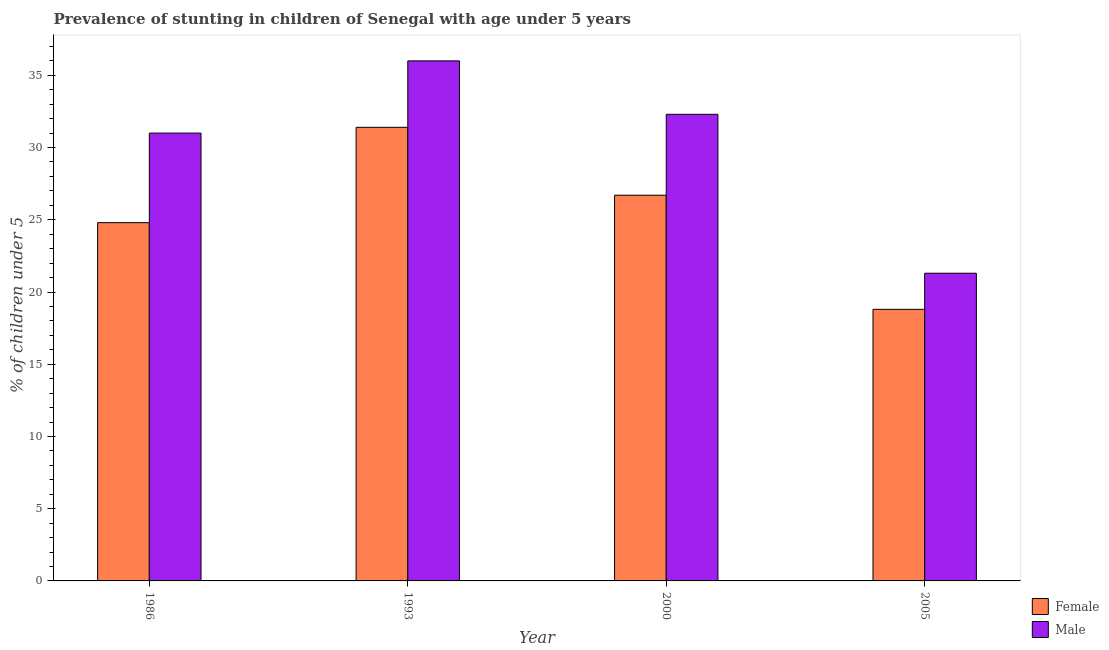How many groups of bars are there?
Your answer should be compact. 4. Are the number of bars per tick equal to the number of legend labels?
Offer a very short reply. Yes. Are the number of bars on each tick of the X-axis equal?
Ensure brevity in your answer.  Yes. How many bars are there on the 2nd tick from the right?
Keep it short and to the point. 2. What is the label of the 2nd group of bars from the left?
Offer a very short reply. 1993. What is the percentage of stunted male children in 1986?
Make the answer very short. 31. Across all years, what is the minimum percentage of stunted female children?
Your answer should be very brief. 18.8. In which year was the percentage of stunted male children minimum?
Provide a short and direct response. 2005. What is the total percentage of stunted male children in the graph?
Ensure brevity in your answer.  120.6. What is the difference between the percentage of stunted male children in 2005 and the percentage of stunted female children in 1986?
Make the answer very short. -9.7. What is the average percentage of stunted male children per year?
Your answer should be very brief. 30.15. What is the ratio of the percentage of stunted female children in 1986 to that in 2000?
Provide a succinct answer. 0.93. Is the difference between the percentage of stunted female children in 1993 and 2000 greater than the difference between the percentage of stunted male children in 1993 and 2000?
Give a very brief answer. No. What is the difference between the highest and the second highest percentage of stunted female children?
Keep it short and to the point. 4.7. What is the difference between the highest and the lowest percentage of stunted male children?
Offer a very short reply. 14.7. Is the sum of the percentage of stunted female children in 1986 and 2000 greater than the maximum percentage of stunted male children across all years?
Ensure brevity in your answer.  Yes. What does the 1st bar from the left in 2005 represents?
Give a very brief answer. Female. What does the 2nd bar from the right in 1993 represents?
Ensure brevity in your answer.  Female. How many bars are there?
Ensure brevity in your answer.  8. How many years are there in the graph?
Offer a terse response. 4. Are the values on the major ticks of Y-axis written in scientific E-notation?
Keep it short and to the point. No. Where does the legend appear in the graph?
Make the answer very short. Bottom right. How many legend labels are there?
Keep it short and to the point. 2. What is the title of the graph?
Provide a short and direct response. Prevalence of stunting in children of Senegal with age under 5 years. Does "Registered firms" appear as one of the legend labels in the graph?
Ensure brevity in your answer.  No. What is the label or title of the Y-axis?
Make the answer very short.  % of children under 5. What is the  % of children under 5 in Female in 1986?
Make the answer very short. 24.8. What is the  % of children under 5 in Male in 1986?
Your answer should be compact. 31. What is the  % of children under 5 of Female in 1993?
Offer a very short reply. 31.4. What is the  % of children under 5 of Male in 1993?
Offer a terse response. 36. What is the  % of children under 5 in Female in 2000?
Provide a short and direct response. 26.7. What is the  % of children under 5 of Male in 2000?
Give a very brief answer. 32.3. What is the  % of children under 5 in Female in 2005?
Your response must be concise. 18.8. What is the  % of children under 5 in Male in 2005?
Ensure brevity in your answer.  21.3. Across all years, what is the maximum  % of children under 5 in Female?
Your answer should be very brief. 31.4. Across all years, what is the maximum  % of children under 5 of Male?
Your answer should be compact. 36. Across all years, what is the minimum  % of children under 5 in Female?
Give a very brief answer. 18.8. Across all years, what is the minimum  % of children under 5 in Male?
Offer a terse response. 21.3. What is the total  % of children under 5 in Female in the graph?
Ensure brevity in your answer.  101.7. What is the total  % of children under 5 of Male in the graph?
Provide a short and direct response. 120.6. What is the difference between the  % of children under 5 in Male in 1986 and that in 1993?
Offer a terse response. -5. What is the difference between the  % of children under 5 in Male in 1986 and that in 2005?
Ensure brevity in your answer.  9.7. What is the difference between the  % of children under 5 in Male in 1993 and that in 2005?
Offer a terse response. 14.7. What is the difference between the  % of children under 5 in Female in 2000 and that in 2005?
Ensure brevity in your answer.  7.9. What is the difference between the  % of children under 5 of Male in 2000 and that in 2005?
Keep it short and to the point. 11. What is the difference between the  % of children under 5 in Female in 1986 and the  % of children under 5 in Male in 2005?
Keep it short and to the point. 3.5. What is the difference between the  % of children under 5 of Female in 1993 and the  % of children under 5 of Male in 2000?
Offer a very short reply. -0.9. What is the difference between the  % of children under 5 of Female in 1993 and the  % of children under 5 of Male in 2005?
Provide a succinct answer. 10.1. What is the difference between the  % of children under 5 in Female in 2000 and the  % of children under 5 in Male in 2005?
Give a very brief answer. 5.4. What is the average  % of children under 5 in Female per year?
Make the answer very short. 25.43. What is the average  % of children under 5 of Male per year?
Ensure brevity in your answer.  30.15. In the year 1986, what is the difference between the  % of children under 5 of Female and  % of children under 5 of Male?
Make the answer very short. -6.2. In the year 1993, what is the difference between the  % of children under 5 in Female and  % of children under 5 in Male?
Your answer should be very brief. -4.6. In the year 2000, what is the difference between the  % of children under 5 of Female and  % of children under 5 of Male?
Your answer should be very brief. -5.6. In the year 2005, what is the difference between the  % of children under 5 of Female and  % of children under 5 of Male?
Ensure brevity in your answer.  -2.5. What is the ratio of the  % of children under 5 in Female in 1986 to that in 1993?
Your answer should be compact. 0.79. What is the ratio of the  % of children under 5 in Male in 1986 to that in 1993?
Keep it short and to the point. 0.86. What is the ratio of the  % of children under 5 of Female in 1986 to that in 2000?
Give a very brief answer. 0.93. What is the ratio of the  % of children under 5 of Male in 1986 to that in 2000?
Provide a short and direct response. 0.96. What is the ratio of the  % of children under 5 of Female in 1986 to that in 2005?
Keep it short and to the point. 1.32. What is the ratio of the  % of children under 5 in Male in 1986 to that in 2005?
Keep it short and to the point. 1.46. What is the ratio of the  % of children under 5 in Female in 1993 to that in 2000?
Give a very brief answer. 1.18. What is the ratio of the  % of children under 5 in Male in 1993 to that in 2000?
Offer a very short reply. 1.11. What is the ratio of the  % of children under 5 of Female in 1993 to that in 2005?
Your response must be concise. 1.67. What is the ratio of the  % of children under 5 in Male in 1993 to that in 2005?
Give a very brief answer. 1.69. What is the ratio of the  % of children under 5 in Female in 2000 to that in 2005?
Your response must be concise. 1.42. What is the ratio of the  % of children under 5 in Male in 2000 to that in 2005?
Offer a terse response. 1.52. What is the difference between the highest and the second highest  % of children under 5 in Male?
Your response must be concise. 3.7. What is the difference between the highest and the lowest  % of children under 5 of Female?
Provide a short and direct response. 12.6. 